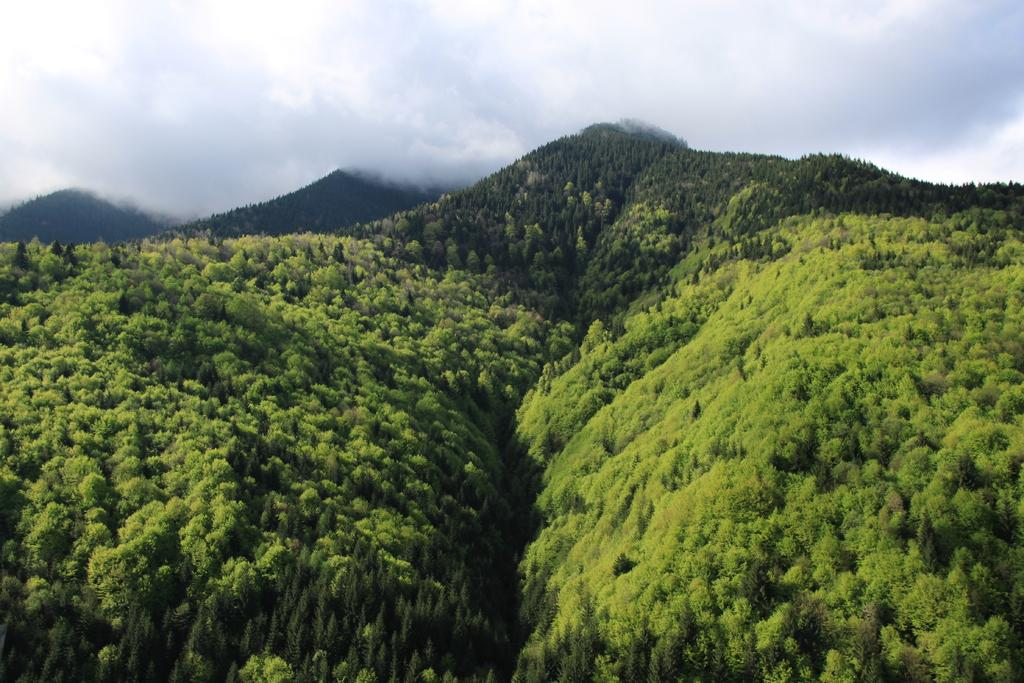Where might the image have been taken? The image might have been taken outside of the city. What type of vegetation can be seen in the image? There are trees in the image. What natural features are visible in the background of the image? There are mountains in the background of the image. What is the weather like in the image? The sky is cloudy in the image. What type of scarf is being used as a caption in the image? There is no scarf or caption present in the image. What type of basket can be seen in the image? There is no basket present in the image. 